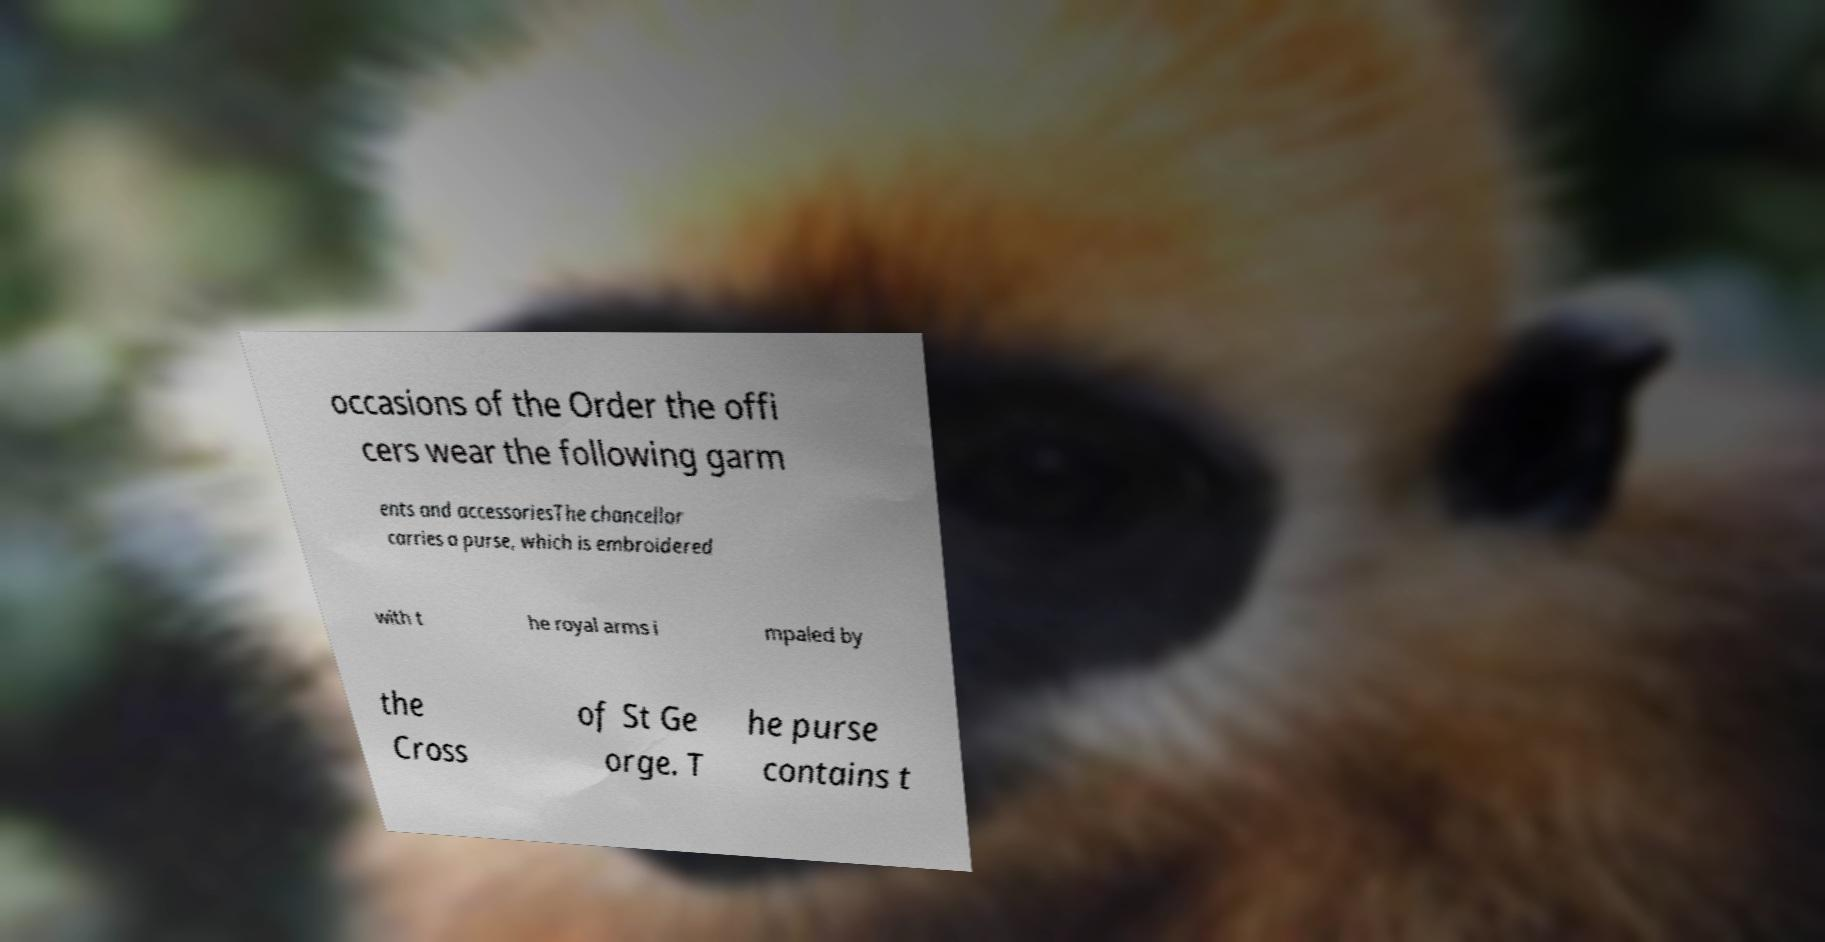Could you assist in decoding the text presented in this image and type it out clearly? occasions of the Order the offi cers wear the following garm ents and accessoriesThe chancellor carries a purse, which is embroidered with t he royal arms i mpaled by the Cross of St Ge orge. T he purse contains t 